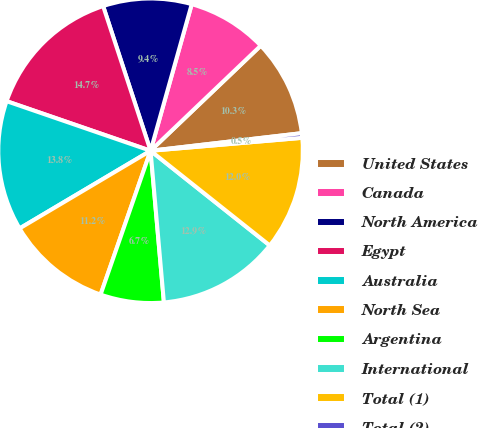Convert chart to OTSL. <chart><loc_0><loc_0><loc_500><loc_500><pie_chart><fcel>United States<fcel>Canada<fcel>North America<fcel>Egypt<fcel>Australia<fcel>North Sea<fcel>Argentina<fcel>International<fcel>Total (1)<fcel>Total (2)<nl><fcel>10.28%<fcel>8.52%<fcel>9.4%<fcel>14.68%<fcel>13.8%<fcel>11.16%<fcel>6.72%<fcel>12.92%<fcel>12.04%<fcel>0.49%<nl></chart> 